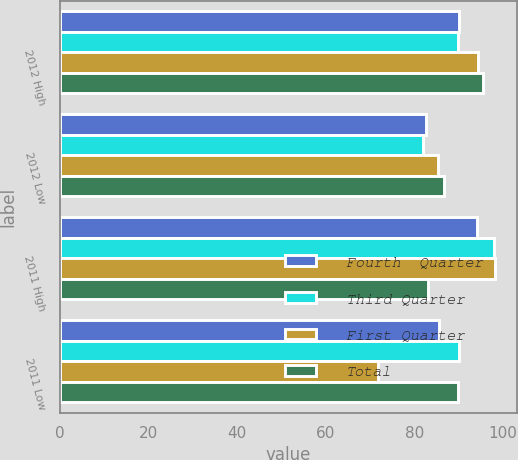Convert chart. <chart><loc_0><loc_0><loc_500><loc_500><stacked_bar_chart><ecel><fcel>2012 High<fcel>2012 Low<fcel>2011 High<fcel>2011 Low<nl><fcel>Fourth  Quarter<fcel>90<fcel>82.7<fcel>94.16<fcel>85.63<nl><fcel>Third Quarter<fcel>89.95<fcel>81.99<fcel>97.95<fcel>90.19<nl><fcel>First Quarter<fcel>94.3<fcel>85.34<fcel>98.19<fcel>71.71<nl><fcel>Total<fcel>95.46<fcel>86.74<fcel>83.1<fcel>89.95<nl></chart> 